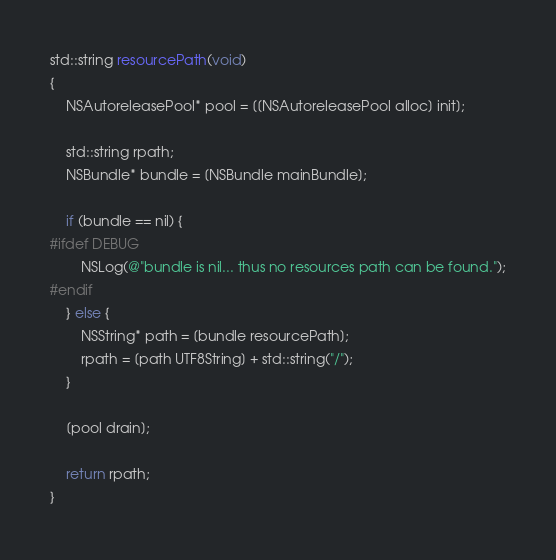Convert code to text. <code><loc_0><loc_0><loc_500><loc_500><_ObjectiveC_>std::string resourcePath(void)
{
    NSAutoreleasePool* pool = [[NSAutoreleasePool alloc] init];

    std::string rpath;
    NSBundle* bundle = [NSBundle mainBundle];

    if (bundle == nil) {
#ifdef DEBUG
        NSLog(@"bundle is nil... thus no resources path can be found.");
#endif
    } else {
        NSString* path = [bundle resourcePath];
        rpath = [path UTF8String] + std::string("/");
    }

    [pool drain];

    return rpath;
}
</code> 